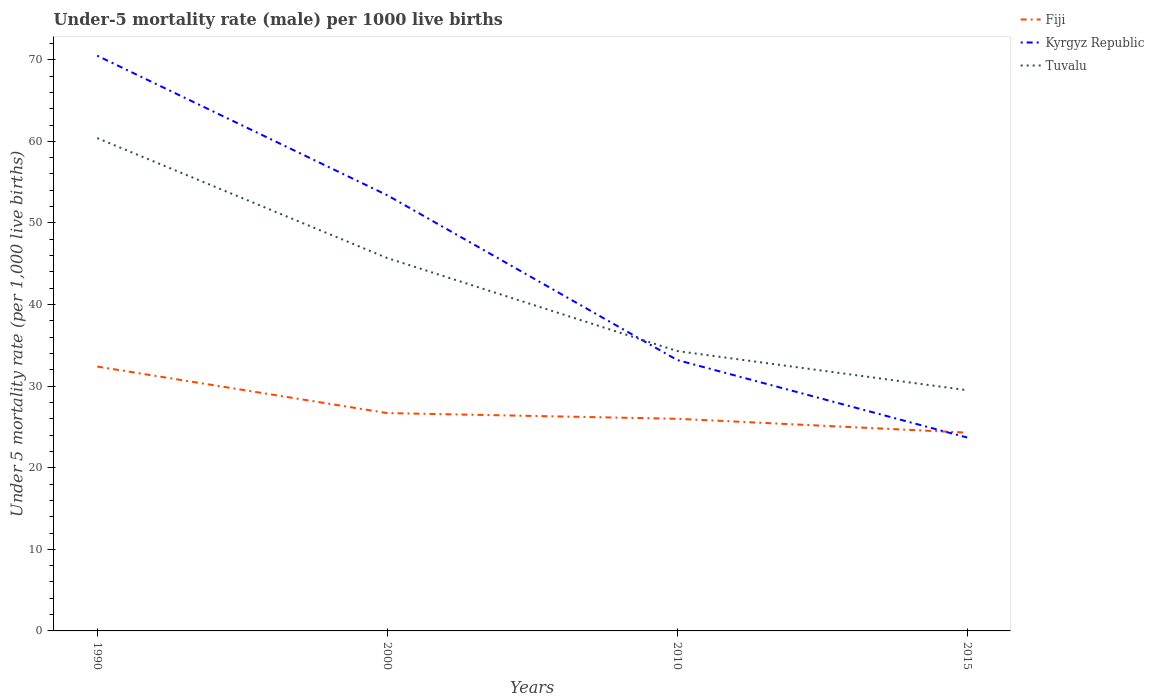Does the line corresponding to Fiji intersect with the line corresponding to Kyrgyz Republic?
Ensure brevity in your answer.  Yes. Across all years, what is the maximum under-five mortality rate in Fiji?
Offer a terse response. 24.3. In which year was the under-five mortality rate in Fiji maximum?
Keep it short and to the point. 2015. What is the total under-five mortality rate in Kyrgyz Republic in the graph?
Provide a short and direct response. 37.3. What is the difference between the highest and the second highest under-five mortality rate in Tuvalu?
Offer a terse response. 30.9. What is the difference between two consecutive major ticks on the Y-axis?
Give a very brief answer. 10. Are the values on the major ticks of Y-axis written in scientific E-notation?
Give a very brief answer. No. Does the graph contain any zero values?
Make the answer very short. No. How many legend labels are there?
Your response must be concise. 3. What is the title of the graph?
Give a very brief answer. Under-5 mortality rate (male) per 1000 live births. Does "Saudi Arabia" appear as one of the legend labels in the graph?
Your answer should be compact. No. What is the label or title of the Y-axis?
Offer a terse response. Under 5 mortality rate (per 1,0 live births). What is the Under 5 mortality rate (per 1,000 live births) in Fiji in 1990?
Keep it short and to the point. 32.4. What is the Under 5 mortality rate (per 1,000 live births) in Kyrgyz Republic in 1990?
Make the answer very short. 70.5. What is the Under 5 mortality rate (per 1,000 live births) of Tuvalu in 1990?
Your response must be concise. 60.4. What is the Under 5 mortality rate (per 1,000 live births) of Fiji in 2000?
Offer a very short reply. 26.7. What is the Under 5 mortality rate (per 1,000 live births) in Kyrgyz Republic in 2000?
Make the answer very short. 53.4. What is the Under 5 mortality rate (per 1,000 live births) of Tuvalu in 2000?
Keep it short and to the point. 45.7. What is the Under 5 mortality rate (per 1,000 live births) in Fiji in 2010?
Your response must be concise. 26. What is the Under 5 mortality rate (per 1,000 live births) in Kyrgyz Republic in 2010?
Your response must be concise. 33.2. What is the Under 5 mortality rate (per 1,000 live births) in Tuvalu in 2010?
Provide a short and direct response. 34.3. What is the Under 5 mortality rate (per 1,000 live births) of Fiji in 2015?
Make the answer very short. 24.3. What is the Under 5 mortality rate (per 1,000 live births) in Kyrgyz Republic in 2015?
Your response must be concise. 23.7. What is the Under 5 mortality rate (per 1,000 live births) in Tuvalu in 2015?
Give a very brief answer. 29.5. Across all years, what is the maximum Under 5 mortality rate (per 1,000 live births) in Fiji?
Offer a very short reply. 32.4. Across all years, what is the maximum Under 5 mortality rate (per 1,000 live births) in Kyrgyz Republic?
Provide a short and direct response. 70.5. Across all years, what is the maximum Under 5 mortality rate (per 1,000 live births) of Tuvalu?
Your answer should be very brief. 60.4. Across all years, what is the minimum Under 5 mortality rate (per 1,000 live births) in Fiji?
Your answer should be compact. 24.3. Across all years, what is the minimum Under 5 mortality rate (per 1,000 live births) in Kyrgyz Republic?
Offer a terse response. 23.7. Across all years, what is the minimum Under 5 mortality rate (per 1,000 live births) of Tuvalu?
Offer a terse response. 29.5. What is the total Under 5 mortality rate (per 1,000 live births) in Fiji in the graph?
Offer a terse response. 109.4. What is the total Under 5 mortality rate (per 1,000 live births) in Kyrgyz Republic in the graph?
Offer a very short reply. 180.8. What is the total Under 5 mortality rate (per 1,000 live births) in Tuvalu in the graph?
Keep it short and to the point. 169.9. What is the difference between the Under 5 mortality rate (per 1,000 live births) of Fiji in 1990 and that in 2000?
Provide a short and direct response. 5.7. What is the difference between the Under 5 mortality rate (per 1,000 live births) in Kyrgyz Republic in 1990 and that in 2000?
Offer a very short reply. 17.1. What is the difference between the Under 5 mortality rate (per 1,000 live births) in Tuvalu in 1990 and that in 2000?
Your response must be concise. 14.7. What is the difference between the Under 5 mortality rate (per 1,000 live births) in Kyrgyz Republic in 1990 and that in 2010?
Offer a very short reply. 37.3. What is the difference between the Under 5 mortality rate (per 1,000 live births) of Tuvalu in 1990 and that in 2010?
Keep it short and to the point. 26.1. What is the difference between the Under 5 mortality rate (per 1,000 live births) of Fiji in 1990 and that in 2015?
Your response must be concise. 8.1. What is the difference between the Under 5 mortality rate (per 1,000 live births) in Kyrgyz Republic in 1990 and that in 2015?
Provide a short and direct response. 46.8. What is the difference between the Under 5 mortality rate (per 1,000 live births) of Tuvalu in 1990 and that in 2015?
Your response must be concise. 30.9. What is the difference between the Under 5 mortality rate (per 1,000 live births) of Fiji in 2000 and that in 2010?
Give a very brief answer. 0.7. What is the difference between the Under 5 mortality rate (per 1,000 live births) in Kyrgyz Republic in 2000 and that in 2010?
Your answer should be compact. 20.2. What is the difference between the Under 5 mortality rate (per 1,000 live births) of Tuvalu in 2000 and that in 2010?
Offer a terse response. 11.4. What is the difference between the Under 5 mortality rate (per 1,000 live births) of Kyrgyz Republic in 2000 and that in 2015?
Make the answer very short. 29.7. What is the difference between the Under 5 mortality rate (per 1,000 live births) of Tuvalu in 2000 and that in 2015?
Ensure brevity in your answer.  16.2. What is the difference between the Under 5 mortality rate (per 1,000 live births) in Fiji in 2010 and that in 2015?
Make the answer very short. 1.7. What is the difference between the Under 5 mortality rate (per 1,000 live births) in Fiji in 1990 and the Under 5 mortality rate (per 1,000 live births) in Tuvalu in 2000?
Offer a terse response. -13.3. What is the difference between the Under 5 mortality rate (per 1,000 live births) in Kyrgyz Republic in 1990 and the Under 5 mortality rate (per 1,000 live births) in Tuvalu in 2000?
Provide a short and direct response. 24.8. What is the difference between the Under 5 mortality rate (per 1,000 live births) in Fiji in 1990 and the Under 5 mortality rate (per 1,000 live births) in Kyrgyz Republic in 2010?
Give a very brief answer. -0.8. What is the difference between the Under 5 mortality rate (per 1,000 live births) in Kyrgyz Republic in 1990 and the Under 5 mortality rate (per 1,000 live births) in Tuvalu in 2010?
Offer a very short reply. 36.2. What is the difference between the Under 5 mortality rate (per 1,000 live births) in Fiji in 1990 and the Under 5 mortality rate (per 1,000 live births) in Kyrgyz Republic in 2015?
Your answer should be compact. 8.7. What is the difference between the Under 5 mortality rate (per 1,000 live births) of Fiji in 2000 and the Under 5 mortality rate (per 1,000 live births) of Kyrgyz Republic in 2010?
Keep it short and to the point. -6.5. What is the difference between the Under 5 mortality rate (per 1,000 live births) in Fiji in 2000 and the Under 5 mortality rate (per 1,000 live births) in Tuvalu in 2010?
Ensure brevity in your answer.  -7.6. What is the difference between the Under 5 mortality rate (per 1,000 live births) of Kyrgyz Republic in 2000 and the Under 5 mortality rate (per 1,000 live births) of Tuvalu in 2015?
Offer a very short reply. 23.9. What is the difference between the Under 5 mortality rate (per 1,000 live births) in Kyrgyz Republic in 2010 and the Under 5 mortality rate (per 1,000 live births) in Tuvalu in 2015?
Your answer should be very brief. 3.7. What is the average Under 5 mortality rate (per 1,000 live births) of Fiji per year?
Provide a short and direct response. 27.35. What is the average Under 5 mortality rate (per 1,000 live births) in Kyrgyz Republic per year?
Give a very brief answer. 45.2. What is the average Under 5 mortality rate (per 1,000 live births) of Tuvalu per year?
Provide a succinct answer. 42.48. In the year 1990, what is the difference between the Under 5 mortality rate (per 1,000 live births) of Fiji and Under 5 mortality rate (per 1,000 live births) of Kyrgyz Republic?
Ensure brevity in your answer.  -38.1. In the year 1990, what is the difference between the Under 5 mortality rate (per 1,000 live births) of Fiji and Under 5 mortality rate (per 1,000 live births) of Tuvalu?
Your response must be concise. -28. In the year 1990, what is the difference between the Under 5 mortality rate (per 1,000 live births) of Kyrgyz Republic and Under 5 mortality rate (per 1,000 live births) of Tuvalu?
Your response must be concise. 10.1. In the year 2000, what is the difference between the Under 5 mortality rate (per 1,000 live births) in Fiji and Under 5 mortality rate (per 1,000 live births) in Kyrgyz Republic?
Offer a very short reply. -26.7. In the year 2000, what is the difference between the Under 5 mortality rate (per 1,000 live births) of Fiji and Under 5 mortality rate (per 1,000 live births) of Tuvalu?
Ensure brevity in your answer.  -19. In the year 2000, what is the difference between the Under 5 mortality rate (per 1,000 live births) of Kyrgyz Republic and Under 5 mortality rate (per 1,000 live births) of Tuvalu?
Keep it short and to the point. 7.7. In the year 2010, what is the difference between the Under 5 mortality rate (per 1,000 live births) in Fiji and Under 5 mortality rate (per 1,000 live births) in Tuvalu?
Provide a short and direct response. -8.3. In the year 2015, what is the difference between the Under 5 mortality rate (per 1,000 live births) in Kyrgyz Republic and Under 5 mortality rate (per 1,000 live births) in Tuvalu?
Offer a very short reply. -5.8. What is the ratio of the Under 5 mortality rate (per 1,000 live births) of Fiji in 1990 to that in 2000?
Make the answer very short. 1.21. What is the ratio of the Under 5 mortality rate (per 1,000 live births) of Kyrgyz Republic in 1990 to that in 2000?
Your answer should be very brief. 1.32. What is the ratio of the Under 5 mortality rate (per 1,000 live births) in Tuvalu in 1990 to that in 2000?
Provide a succinct answer. 1.32. What is the ratio of the Under 5 mortality rate (per 1,000 live births) in Fiji in 1990 to that in 2010?
Your answer should be compact. 1.25. What is the ratio of the Under 5 mortality rate (per 1,000 live births) in Kyrgyz Republic in 1990 to that in 2010?
Give a very brief answer. 2.12. What is the ratio of the Under 5 mortality rate (per 1,000 live births) in Tuvalu in 1990 to that in 2010?
Keep it short and to the point. 1.76. What is the ratio of the Under 5 mortality rate (per 1,000 live births) in Kyrgyz Republic in 1990 to that in 2015?
Provide a succinct answer. 2.97. What is the ratio of the Under 5 mortality rate (per 1,000 live births) in Tuvalu in 1990 to that in 2015?
Your response must be concise. 2.05. What is the ratio of the Under 5 mortality rate (per 1,000 live births) in Fiji in 2000 to that in 2010?
Your response must be concise. 1.03. What is the ratio of the Under 5 mortality rate (per 1,000 live births) in Kyrgyz Republic in 2000 to that in 2010?
Your answer should be very brief. 1.61. What is the ratio of the Under 5 mortality rate (per 1,000 live births) in Tuvalu in 2000 to that in 2010?
Offer a very short reply. 1.33. What is the ratio of the Under 5 mortality rate (per 1,000 live births) of Fiji in 2000 to that in 2015?
Ensure brevity in your answer.  1.1. What is the ratio of the Under 5 mortality rate (per 1,000 live births) of Kyrgyz Republic in 2000 to that in 2015?
Ensure brevity in your answer.  2.25. What is the ratio of the Under 5 mortality rate (per 1,000 live births) in Tuvalu in 2000 to that in 2015?
Offer a very short reply. 1.55. What is the ratio of the Under 5 mortality rate (per 1,000 live births) of Fiji in 2010 to that in 2015?
Provide a short and direct response. 1.07. What is the ratio of the Under 5 mortality rate (per 1,000 live births) in Kyrgyz Republic in 2010 to that in 2015?
Your answer should be compact. 1.4. What is the ratio of the Under 5 mortality rate (per 1,000 live births) of Tuvalu in 2010 to that in 2015?
Offer a very short reply. 1.16. What is the difference between the highest and the second highest Under 5 mortality rate (per 1,000 live births) of Fiji?
Offer a terse response. 5.7. What is the difference between the highest and the lowest Under 5 mortality rate (per 1,000 live births) of Fiji?
Your answer should be very brief. 8.1. What is the difference between the highest and the lowest Under 5 mortality rate (per 1,000 live births) in Kyrgyz Republic?
Give a very brief answer. 46.8. What is the difference between the highest and the lowest Under 5 mortality rate (per 1,000 live births) of Tuvalu?
Give a very brief answer. 30.9. 